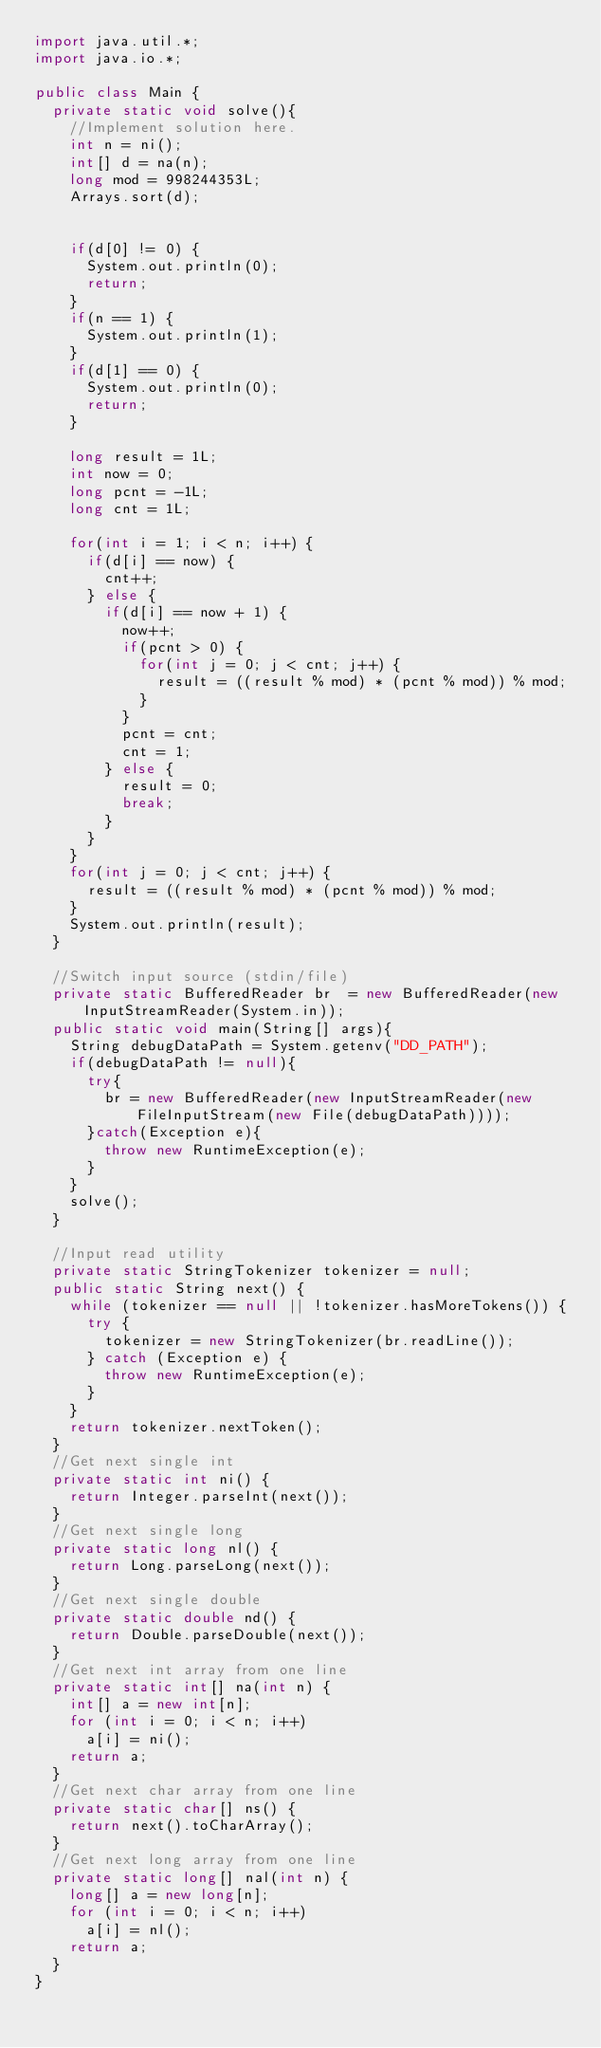Convert code to text. <code><loc_0><loc_0><loc_500><loc_500><_Java_>import java.util.*;
import java.io.*;

public class Main {
	private static void solve(){
		//Implement solution here.
		int n = ni();
		int[] d = na(n);
		long mod = 998244353L;
		Arrays.sort(d);		


		if(d[0] != 0) {
			System.out.println(0);
			return;
		}
		if(n == 1) {
			System.out.println(1);
		}
		if(d[1] == 0) {
			System.out.println(0);
			return;
		}

		long result = 1L;		
		int now = 0;
		long pcnt = -1L;
		long cnt = 1L;

		for(int i = 1; i < n; i++) {			
			if(d[i] == now) {
				cnt++;
			} else {
				if(d[i] == now + 1) {
					now++;
					if(pcnt > 0) {
						for(int j = 0; j < cnt; j++) {
							result = ((result % mod) * (pcnt % mod)) % mod;
						}											
					}
					pcnt = cnt;
					cnt = 1;					
				} else {
					result = 0;
					break;
				}
			}
		}
		for(int j = 0; j < cnt; j++) {
			result = ((result % mod) * (pcnt % mod)) % mod;
		}		
		System.out.println(result);
	}

	//Switch input source (stdin/file)
	private static BufferedReader br  = new BufferedReader(new InputStreamReader(System.in));
	public static void main(String[] args){
		String debugDataPath = System.getenv("DD_PATH");        
		if(debugDataPath != null){
			try{
				br = new BufferedReader(new InputStreamReader(new FileInputStream(new File(debugDataPath))));
			}catch(Exception e){
				throw new RuntimeException(e);
			}
		}
		solve();
	}

	//Input read utility
	private static StringTokenizer tokenizer = null;
	public static String next() {
		while (tokenizer == null || !tokenizer.hasMoreTokens()) {
			try {
				tokenizer = new StringTokenizer(br.readLine());
			} catch (Exception e) {
				throw new RuntimeException(e);
			}
		}
		return tokenizer.nextToken();
	}
	//Get next single int
	private static int ni() {
		return Integer.parseInt(next());
	}
	//Get next single long
	private static long nl() {
		return Long.parseLong(next());
	}
	//Get next single double
	private static double nd() {
		return Double.parseDouble(next());
	}
	//Get next int array from one line
	private static int[] na(int n) {
		int[] a = new int[n];
		for (int i = 0; i < n; i++)
			a[i] = ni();
		return a;
	}
	//Get next char array from one line
	private static char[] ns() {
		return next().toCharArray();
	}
	//Get next long array from one line
	private static long[] nal(int n) {
		long[] a = new long[n];
		for (int i = 0; i < n; i++)
			a[i] = nl();
		return a;
	}
}</code> 